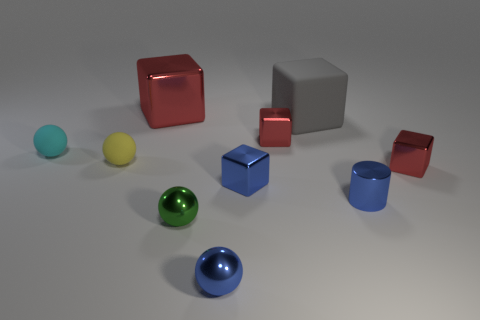How many things are either small blue metallic objects that are in front of the tiny green shiny sphere or small rubber spheres?
Provide a short and direct response. 3. Do the tiny yellow thing and the big cube behind the matte cube have the same material?
Provide a short and direct response. No. What shape is the blue thing in front of the small metal ball behind the blue ball?
Keep it short and to the point. Sphere. Does the large metal object have the same color as the tiny shiny cylinder that is to the right of the gray rubber thing?
Your answer should be very brief. No. Is there any other thing that is the same material as the small cyan ball?
Offer a very short reply. Yes. What is the shape of the yellow object?
Your answer should be compact. Sphere. There is a shiny object behind the large object that is right of the tiny blue sphere; how big is it?
Give a very brief answer. Large. Are there the same number of blue shiny balls behind the tiny blue metallic ball and large gray things that are on the right side of the blue cylinder?
Give a very brief answer. Yes. What is the red thing that is both behind the tiny cyan ball and right of the large red metal object made of?
Provide a succinct answer. Metal. There is a blue ball; is it the same size as the red cube that is in front of the small cyan thing?
Offer a very short reply. Yes. 